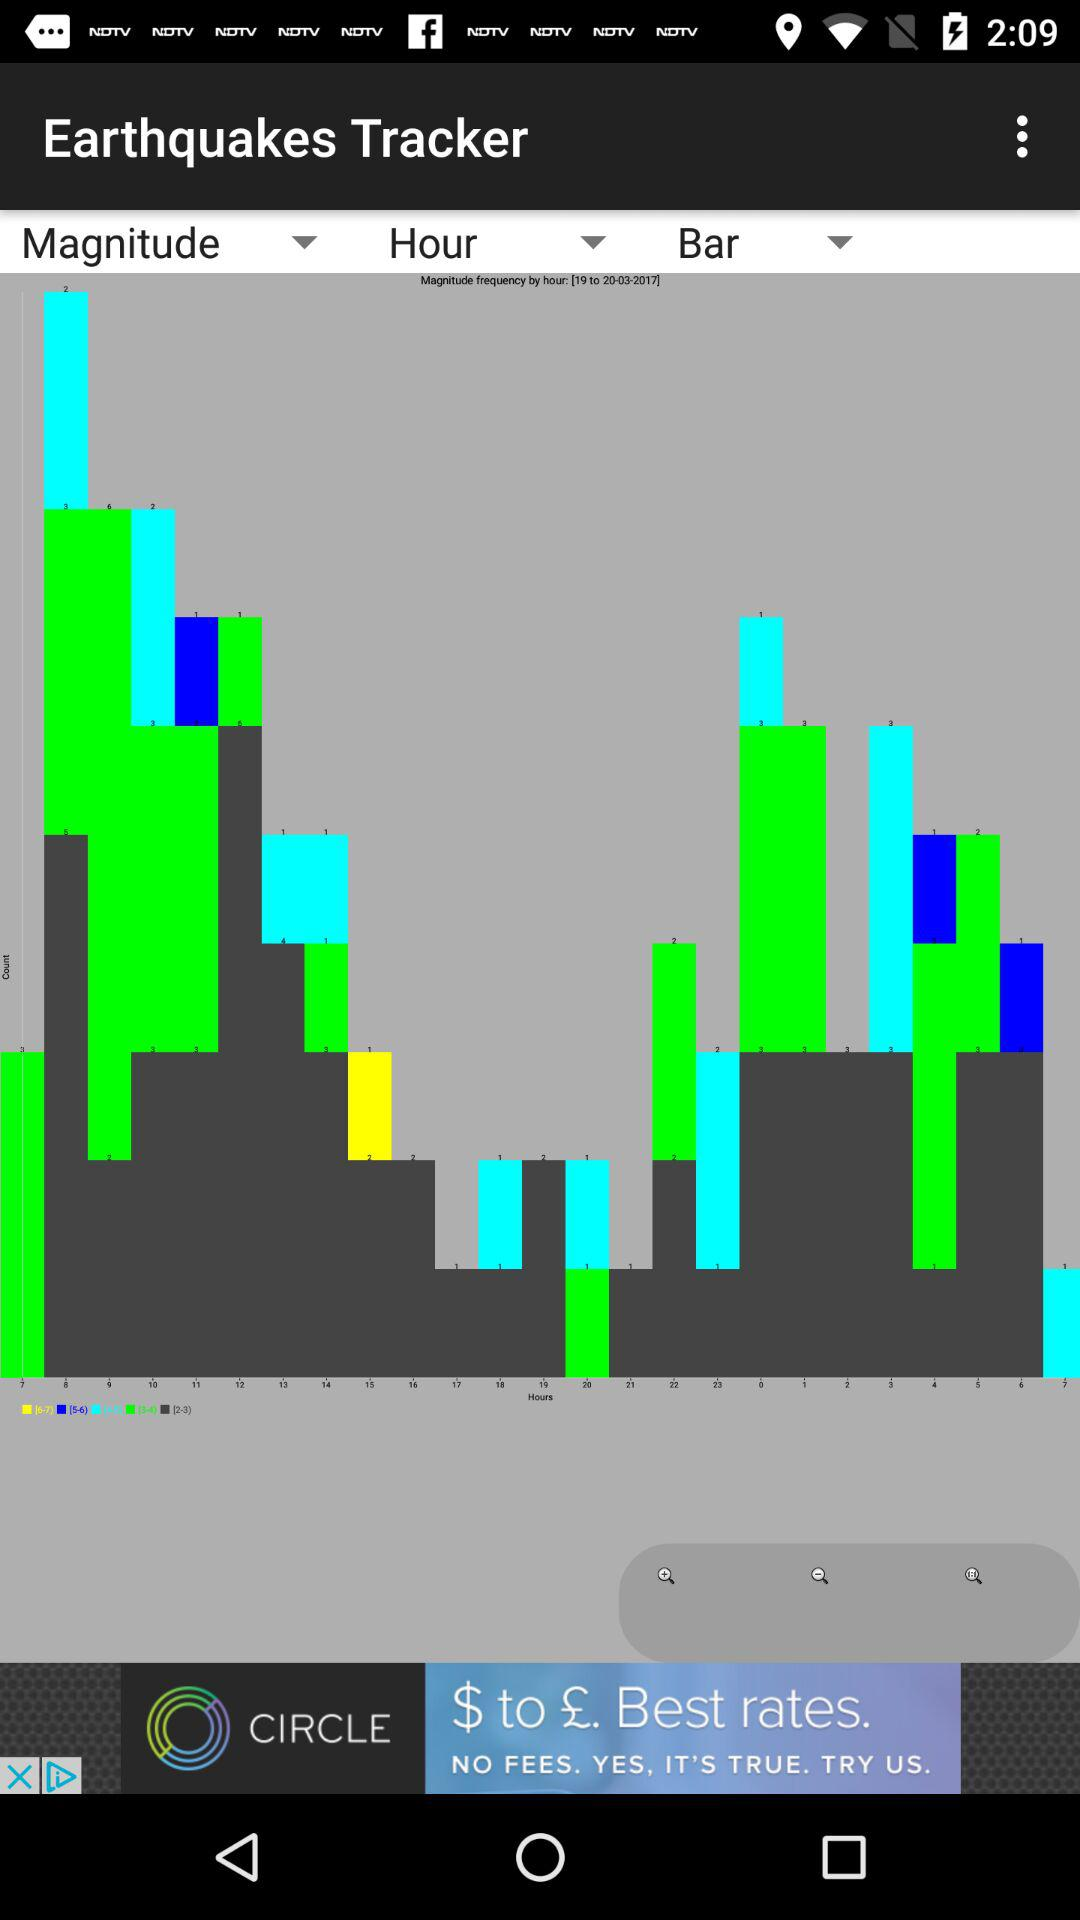When was "Earthquakes Tracker" released?
When the provided information is insufficient, respond with <no answer>. <no answer> 